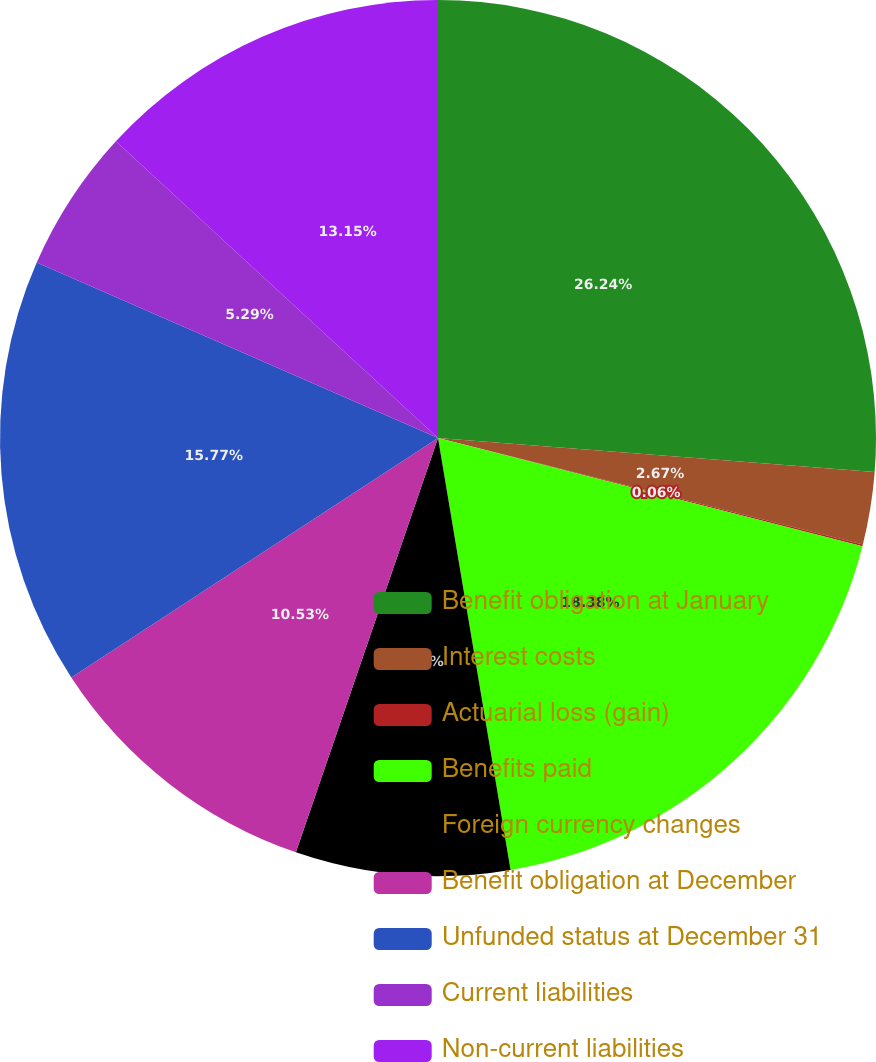Convert chart to OTSL. <chart><loc_0><loc_0><loc_500><loc_500><pie_chart><fcel>Benefit obligation at January<fcel>Interest costs<fcel>Actuarial loss (gain)<fcel>Benefits paid<fcel>Foreign currency changes<fcel>Benefit obligation at December<fcel>Unfunded status at December 31<fcel>Current liabilities<fcel>Non-current liabilities<nl><fcel>26.24%<fcel>2.67%<fcel>0.06%<fcel>18.38%<fcel>7.91%<fcel>10.53%<fcel>15.77%<fcel>5.29%<fcel>13.15%<nl></chart> 